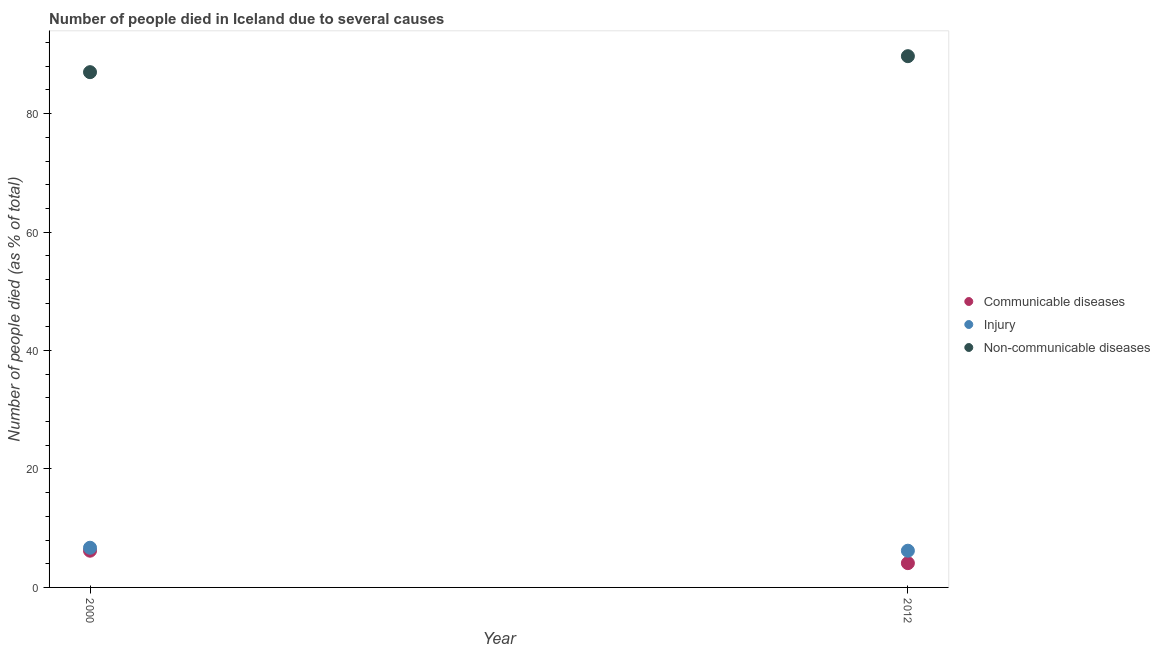Is the number of dotlines equal to the number of legend labels?
Offer a very short reply. Yes. Across all years, what is the maximum number of people who died of injury?
Keep it short and to the point. 6.7. In which year was the number of people who dies of non-communicable diseases maximum?
Your answer should be compact. 2012. What is the total number of people who dies of non-communicable diseases in the graph?
Offer a terse response. 176.7. What is the difference between the number of people who died of injury in 2012 and the number of people who dies of non-communicable diseases in 2000?
Ensure brevity in your answer.  -80.8. What is the average number of people who died of injury per year?
Your answer should be very brief. 6.45. In how many years, is the number of people who died of communicable diseases greater than 48 %?
Your response must be concise. 0. What is the ratio of the number of people who died of communicable diseases in 2000 to that in 2012?
Offer a terse response. 1.51. In how many years, is the number of people who died of injury greater than the average number of people who died of injury taken over all years?
Give a very brief answer. 1. Is it the case that in every year, the sum of the number of people who died of communicable diseases and number of people who died of injury is greater than the number of people who dies of non-communicable diseases?
Keep it short and to the point. No. Does the number of people who died of injury monotonically increase over the years?
Give a very brief answer. No. Is the number of people who dies of non-communicable diseases strictly greater than the number of people who died of injury over the years?
Your response must be concise. Yes. How many dotlines are there?
Give a very brief answer. 3. What is the difference between two consecutive major ticks on the Y-axis?
Provide a short and direct response. 20. Does the graph contain grids?
Your response must be concise. No. How many legend labels are there?
Ensure brevity in your answer.  3. How are the legend labels stacked?
Make the answer very short. Vertical. What is the title of the graph?
Provide a succinct answer. Number of people died in Iceland due to several causes. Does "Travel services" appear as one of the legend labels in the graph?
Offer a very short reply. No. What is the label or title of the Y-axis?
Offer a very short reply. Number of people died (as % of total). What is the Number of people died (as % of total) in Non-communicable diseases in 2000?
Your response must be concise. 87. What is the Number of people died (as % of total) of Non-communicable diseases in 2012?
Make the answer very short. 89.7. Across all years, what is the maximum Number of people died (as % of total) in Communicable diseases?
Provide a succinct answer. 6.2. Across all years, what is the maximum Number of people died (as % of total) in Non-communicable diseases?
Keep it short and to the point. 89.7. Across all years, what is the minimum Number of people died (as % of total) of Communicable diseases?
Your answer should be compact. 4.1. Across all years, what is the minimum Number of people died (as % of total) of Injury?
Your answer should be compact. 6.2. Across all years, what is the minimum Number of people died (as % of total) in Non-communicable diseases?
Make the answer very short. 87. What is the total Number of people died (as % of total) in Non-communicable diseases in the graph?
Your response must be concise. 176.7. What is the difference between the Number of people died (as % of total) in Communicable diseases in 2000 and the Number of people died (as % of total) in Injury in 2012?
Give a very brief answer. 0. What is the difference between the Number of people died (as % of total) of Communicable diseases in 2000 and the Number of people died (as % of total) of Non-communicable diseases in 2012?
Give a very brief answer. -83.5. What is the difference between the Number of people died (as % of total) of Injury in 2000 and the Number of people died (as % of total) of Non-communicable diseases in 2012?
Make the answer very short. -83. What is the average Number of people died (as % of total) of Communicable diseases per year?
Provide a succinct answer. 5.15. What is the average Number of people died (as % of total) in Injury per year?
Your answer should be very brief. 6.45. What is the average Number of people died (as % of total) in Non-communicable diseases per year?
Give a very brief answer. 88.35. In the year 2000, what is the difference between the Number of people died (as % of total) of Communicable diseases and Number of people died (as % of total) of Injury?
Offer a terse response. -0.5. In the year 2000, what is the difference between the Number of people died (as % of total) of Communicable diseases and Number of people died (as % of total) of Non-communicable diseases?
Your answer should be compact. -80.8. In the year 2000, what is the difference between the Number of people died (as % of total) in Injury and Number of people died (as % of total) in Non-communicable diseases?
Your answer should be very brief. -80.3. In the year 2012, what is the difference between the Number of people died (as % of total) of Communicable diseases and Number of people died (as % of total) of Non-communicable diseases?
Ensure brevity in your answer.  -85.6. In the year 2012, what is the difference between the Number of people died (as % of total) in Injury and Number of people died (as % of total) in Non-communicable diseases?
Make the answer very short. -83.5. What is the ratio of the Number of people died (as % of total) of Communicable diseases in 2000 to that in 2012?
Ensure brevity in your answer.  1.51. What is the ratio of the Number of people died (as % of total) in Injury in 2000 to that in 2012?
Keep it short and to the point. 1.08. What is the ratio of the Number of people died (as % of total) of Non-communicable diseases in 2000 to that in 2012?
Give a very brief answer. 0.97. What is the difference between the highest and the second highest Number of people died (as % of total) in Non-communicable diseases?
Give a very brief answer. 2.7. What is the difference between the highest and the lowest Number of people died (as % of total) of Non-communicable diseases?
Keep it short and to the point. 2.7. 